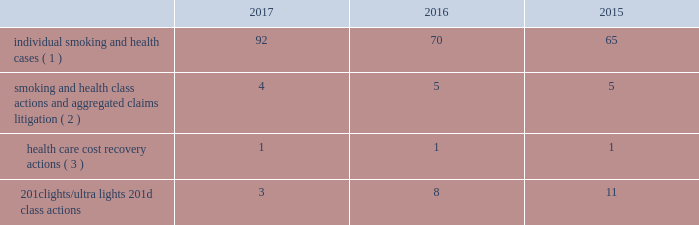10-k altria ar release tuesday , february 27 , 2018 10:00pm andra design llc verdicts have been appealed , there remains a risk that such relief may not be obtainable in all cases .
This risk has been substantially reduced given that 47 states and puerto rico limit the dollar amount of bonds or require no bond at all .
As discussed below , however , tobacco litigation plaintiffs have challenged the constitutionality of florida 2019s bond cap statute in several cases and plaintiffs may challenge state bond cap statutes in other jurisdictions as well .
Such challenges may include the applicability of state bond caps in federal court .
States , including florida , may also seek to repeal or alter bond cap statutes through legislation .
Although altria group , inc .
Cannot predict the outcome of such challenges , it is possible that the consolidated results of operations , cash flows or financial position of altria group , inc. , or one or more of its subsidiaries , could be materially affected in a particular fiscal quarter or fiscal year by an unfavorable outcome of one or more such challenges .
Altria group , inc .
And its subsidiaries record provisions in the consolidated financial statements for pending litigation when they determine that an unfavorable outcome is probable and the amount of the loss can be reasonably estimated .
At the present time , while it is reasonably possible that an unfavorable outcome in a case may occur , except to the extent discussed elsewhere in this note 18 .
Contingencies : ( i ) management has concluded that it is not probable that a loss has been incurred in any of the pending tobacco-related cases ; ( ii ) management is unable to estimate the possible loss or range of loss that could result from an unfavorable outcome in any of the pending tobacco-related cases ; and ( iii ) accordingly , management has not provided any amounts in the consolidated financial statements for unfavorable outcomes , if any .
Litigation defense costs are expensed as incurred .
Altria group , inc .
And its subsidiaries have achieved substantial success in managing litigation .
Nevertheless , litigation is subject to uncertainty and significant challenges remain .
It is possible that the consolidated results of operations , cash flows or financial position of altria group , inc. , or one or more of its subsidiaries , could be materially affected in a particular fiscal quarter or fiscal year by an unfavorable outcome or settlement of certain pending litigation .
Altria group , inc .
And each of its subsidiaries named as a defendant believe , and each has been so advised by counsel handling the respective cases , that it has valid defenses to the litigation pending against it , as well as valid bases for appeal of adverse verdicts .
Each of the companies has defended , and will continue to defend , vigorously against litigation challenges .
However , altria group , inc .
And its subsidiaries may enter into settlement discussions in particular cases if they believe it is in the best interests of altria group , inc .
To do so .
Overview of altria group , inc .
And/or pm usa tobacco- related litigation types and number of cases : claims related to tobacco products generally fall within the following categories : ( i ) smoking and health cases alleging personal injury brought on behalf of individual plaintiffs ; ( ii ) smoking and health cases primarily alleging personal injury or seeking court-supervised programs for ongoing medical monitoring and purporting to be brought on behalf of a class of individual plaintiffs , including cases in which the aggregated claims of a number of individual plaintiffs are to be tried in a single proceeding ; ( iii ) health care cost recovery cases brought by governmental ( both domestic and foreign ) plaintiffs seeking reimbursement for health care expenditures allegedly caused by cigarette smoking and/or disgorgement of profits ; ( iv ) class action suits alleging that the uses of the terms 201clights 201d and 201cultra lights 201d constitute deceptive and unfair trade practices , common law or statutory fraud , unjust enrichment , breach of warranty or violations of the racketeer influenced and corrupt organizations act ( 201crico 201d ) ; and ( v ) other tobacco-related litigation described below .
Plaintiffs 2019 theories of recovery and the defenses raised in pending smoking and health , health care cost recovery and 201clights/ultra lights 201d cases are discussed below .
The table below lists the number of certain tobacco-related cases pending in the united states against pm usa and , in some instances , altria group , inc .
As of december 31 , 2017 , 2016 and .
( 1 ) does not include 2414 cases brought by flight attendants seeking compensatory damages for personal injuries allegedly caused by exposure to environmental tobacco smoke ( 201cets 201d ) .
The flight attendants allege that they are members of an ets smoking and health class action in florida , which was settled in 1997 ( broin ) .
The terms of the court-approved settlement in that case allowed class members to file individual lawsuits seeking compensatory damages , but prohibited them from seeking punitive damages .
Also , does not include individual smoking and health cases brought by or on behalf of plaintiffs in florida state and federal courts following the decertification of the engle case ( discussed below in smoking and health litigation - engle class action ) .
( 2 ) includes as one case the 30 civil actions that were to be tried in six consolidated trials in west virginia ( in re : tobacco litigation ) .
Pm usa is a defendant in nine of the 30 cases .
The parties have agreed to resolve the cases for an immaterial amount and have so notified the court .
( 3 ) see health care cost recovery litigation - federal government 2019s lawsuit below .
International tobacco-related cases : as of january 29 , 2018 , pm usa is a named defendant in 10 health care cost recovery actions in canada , eight of which also name altria group , inc .
As a defendant .
Pm usa and altria group , inc .
Are also named defendants in seven smoking and health class actions filed in various canadian provinces .
See guarantees and other similar matters below for a discussion of the distribution agreement between altria group , inc .
And pmi that provides for indemnities for certain liabilities concerning tobacco products. .
What are the total number of pending tobacco-related cases in united states in 2016? 
Computations: (((70 + 5) + 1) + 8)
Answer: 84.0. 